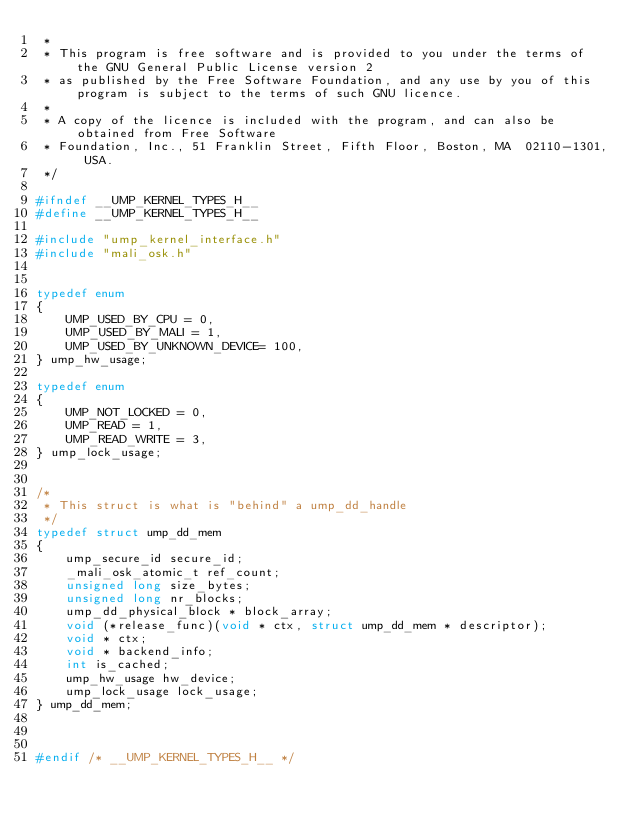<code> <loc_0><loc_0><loc_500><loc_500><_C_> * 
 * This program is free software and is provided to you under the terms of the GNU General Public License version 2
 * as published by the Free Software Foundation, and any use by you of this program is subject to the terms of such GNU licence.
 * 
 * A copy of the licence is included with the program, and can also be obtained from Free Software
 * Foundation, Inc., 51 Franklin Street, Fifth Floor, Boston, MA  02110-1301, USA.
 */

#ifndef __UMP_KERNEL_TYPES_H__
#define __UMP_KERNEL_TYPES_H__

#include "ump_kernel_interface.h"
#include "mali_osk.h"


typedef enum
{
	UMP_USED_BY_CPU = 0,
	UMP_USED_BY_MALI = 1,
	UMP_USED_BY_UNKNOWN_DEVICE= 100,
} ump_hw_usage;

typedef enum
{
	UMP_NOT_LOCKED = 0,
	UMP_READ = 1,
	UMP_READ_WRITE = 3,
} ump_lock_usage;


/*
 * This struct is what is "behind" a ump_dd_handle
 */
typedef struct ump_dd_mem
{
	ump_secure_id secure_id;
	_mali_osk_atomic_t ref_count;
	unsigned long size_bytes;
	unsigned long nr_blocks;
	ump_dd_physical_block * block_array;
	void (*release_func)(void * ctx, struct ump_dd_mem * descriptor);
	void * ctx;
	void * backend_info;
	int is_cached;
	ump_hw_usage hw_device;
	ump_lock_usage lock_usage;
} ump_dd_mem;



#endif /* __UMP_KERNEL_TYPES_H__ */
</code> 